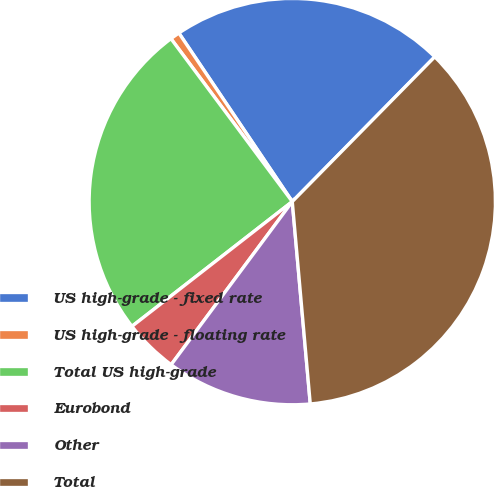Convert chart to OTSL. <chart><loc_0><loc_0><loc_500><loc_500><pie_chart><fcel>US high-grade - fixed rate<fcel>US high-grade - floating rate<fcel>Total US high-grade<fcel>Eurobond<fcel>Other<fcel>Total<nl><fcel>21.8%<fcel>0.76%<fcel>25.34%<fcel>4.31%<fcel>11.58%<fcel>36.22%<nl></chart> 